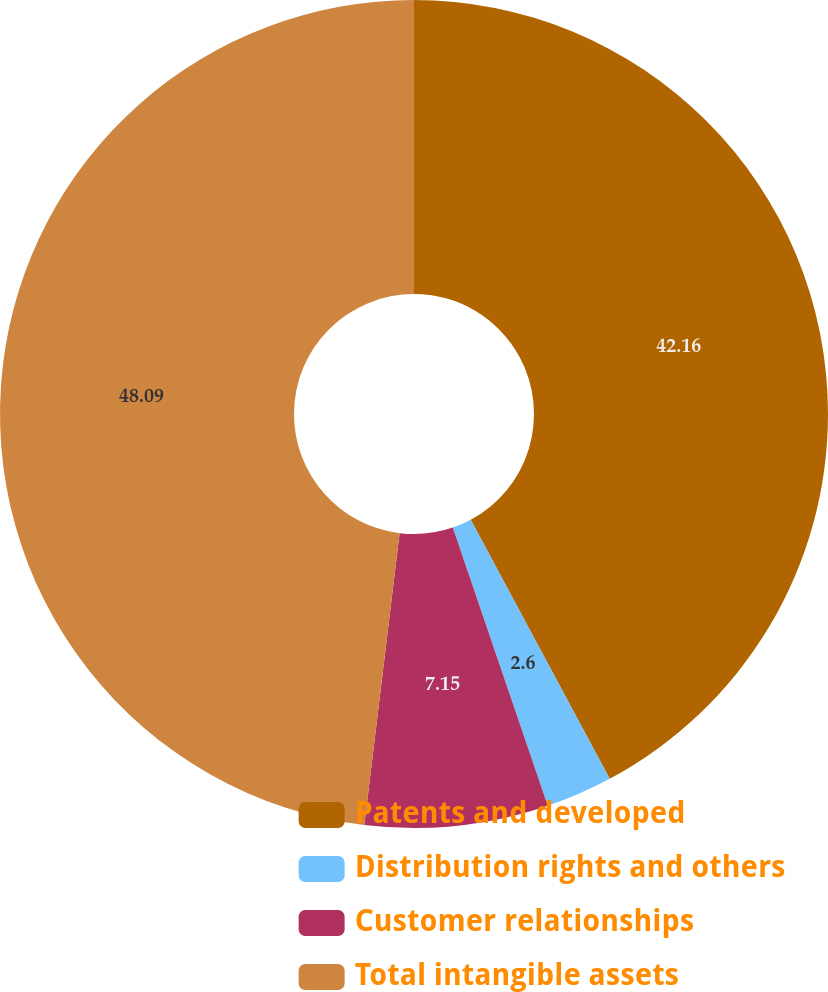Convert chart to OTSL. <chart><loc_0><loc_0><loc_500><loc_500><pie_chart><fcel>Patents and developed<fcel>Distribution rights and others<fcel>Customer relationships<fcel>Total intangible assets<nl><fcel>42.16%<fcel>2.6%<fcel>7.15%<fcel>48.08%<nl></chart> 